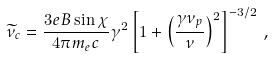<formula> <loc_0><loc_0><loc_500><loc_500>\widetilde { \nu } _ { c } = \frac { 3 e B \sin \chi } { 4 \pi m _ { e } c } \gamma ^ { 2 } \left [ 1 + \left ( \frac { \gamma \nu _ { p } } { \nu } \right ) ^ { 2 } \right ] ^ { - 3 / 2 } \, ,</formula> 